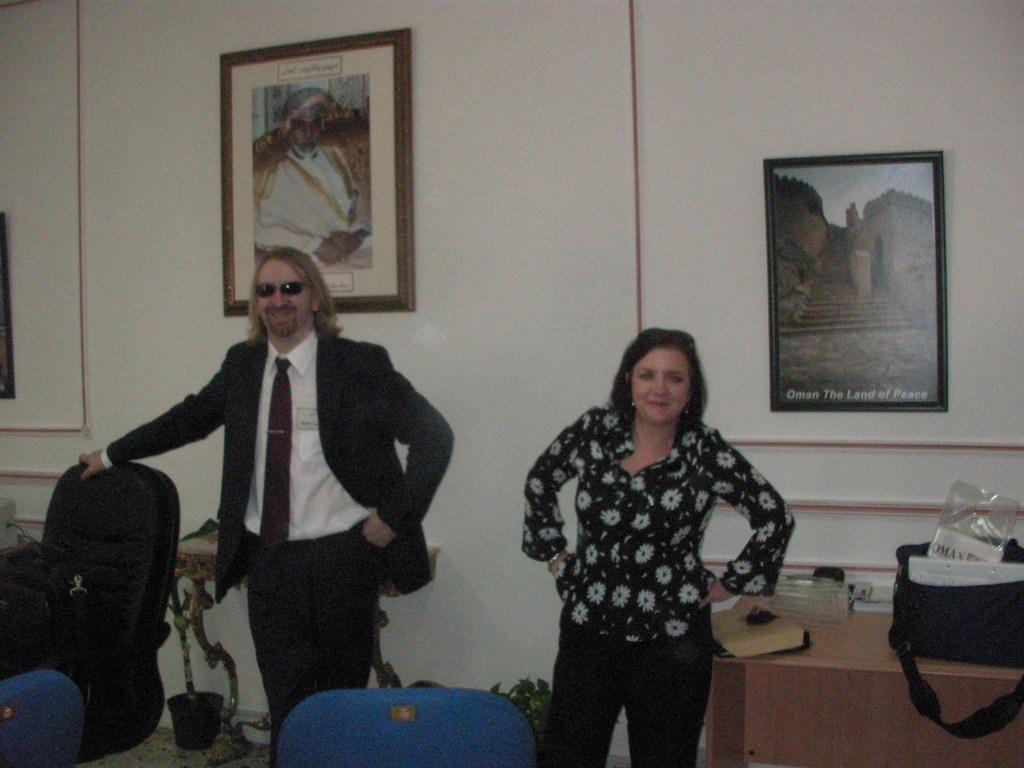Could you give a brief overview of what you see in this image? In this image I can see few persons standing and they both are wearing black color shirts and on the left side I can see chairs and on the right side I can see a table and bag and paper and table , at the top I can see the wall and photo frames attached to the wall. 